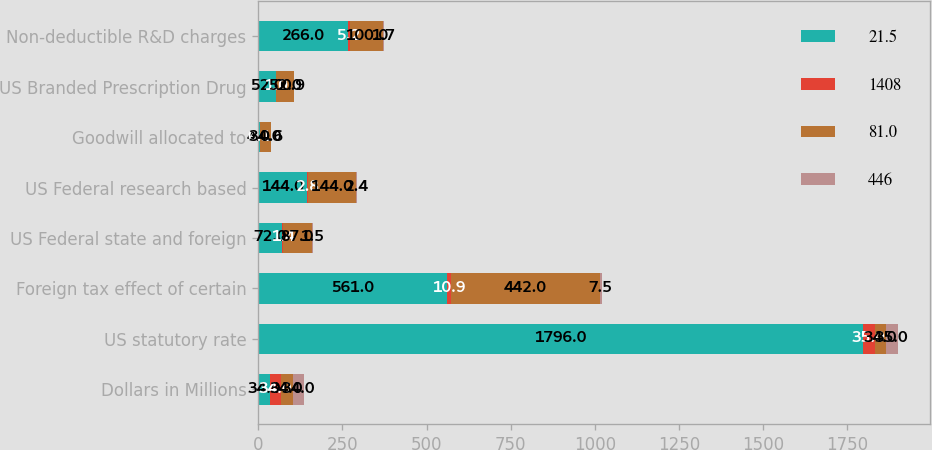<chart> <loc_0><loc_0><loc_500><loc_500><stacked_bar_chart><ecel><fcel>Dollars in Millions<fcel>US statutory rate<fcel>Foreign tax effect of certain<fcel>US Federal state and foreign<fcel>US Federal research based<fcel>Goodwill allocated to<fcel>US Branded Prescription Drug<fcel>Non-deductible R&D charges<nl><fcel>21.5<fcel>34<fcel>1796<fcel>561<fcel>72<fcel>144<fcel>4<fcel>52<fcel>266<nl><fcel>1408<fcel>34<fcel>35<fcel>10.9<fcel>1.4<fcel>2.8<fcel>0.1<fcel>1<fcel>5.2<nl><fcel>81<fcel>34<fcel>34<fcel>442<fcel>87<fcel>144<fcel>34<fcel>52<fcel>100<nl><fcel>446<fcel>34<fcel>35<fcel>7.5<fcel>1.5<fcel>2.4<fcel>0.6<fcel>0.9<fcel>1.7<nl></chart> 